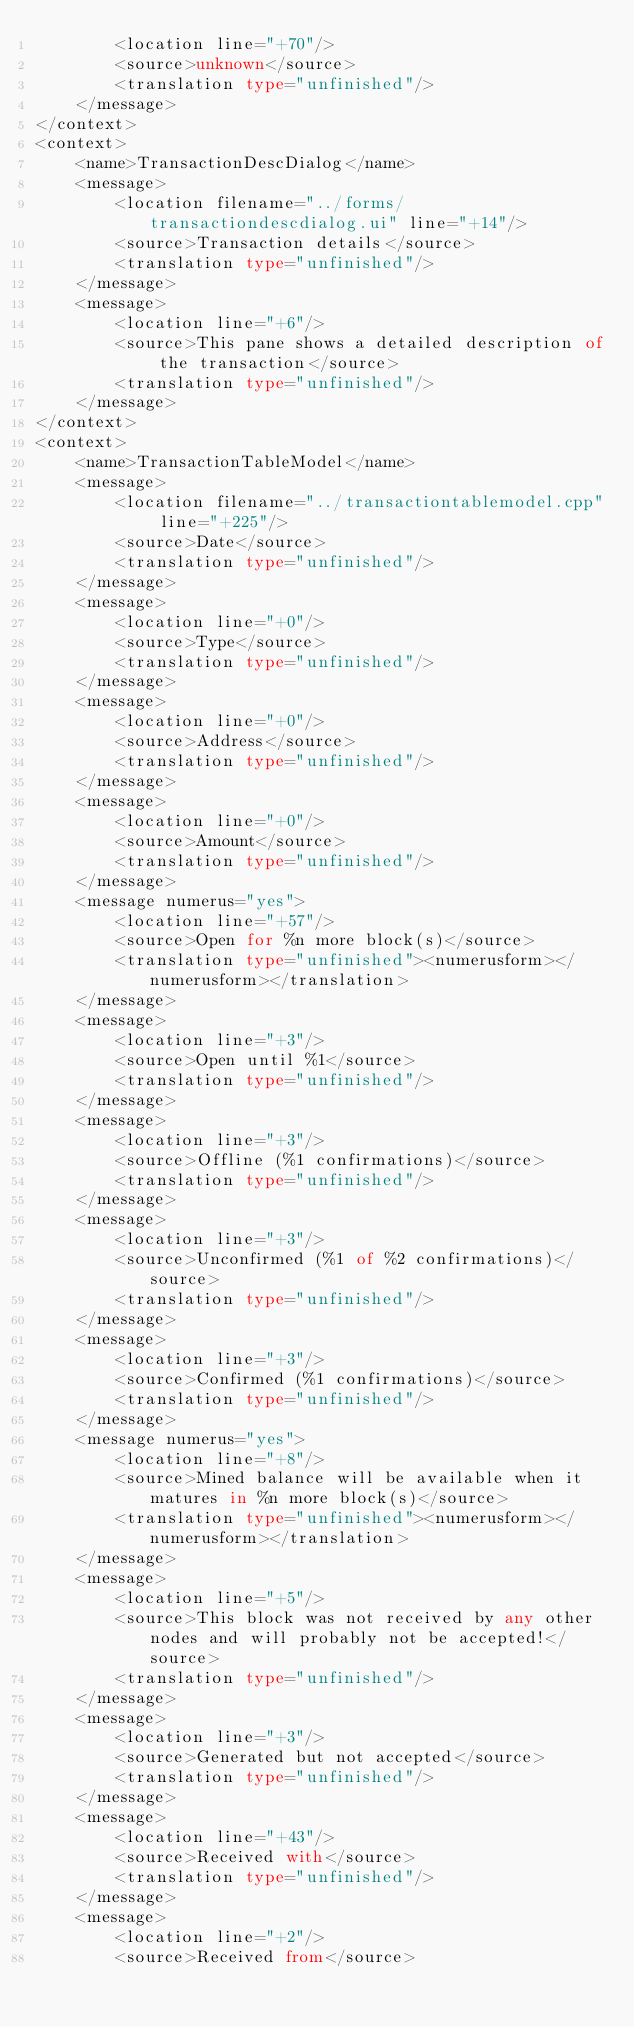Convert code to text. <code><loc_0><loc_0><loc_500><loc_500><_TypeScript_>        <location line="+70"/>
        <source>unknown</source>
        <translation type="unfinished"/>
    </message>
</context>
<context>
    <name>TransactionDescDialog</name>
    <message>
        <location filename="../forms/transactiondescdialog.ui" line="+14"/>
        <source>Transaction details</source>
        <translation type="unfinished"/>
    </message>
    <message>
        <location line="+6"/>
        <source>This pane shows a detailed description of the transaction</source>
        <translation type="unfinished"/>
    </message>
</context>
<context>
    <name>TransactionTableModel</name>
    <message>
        <location filename="../transactiontablemodel.cpp" line="+225"/>
        <source>Date</source>
        <translation type="unfinished"/>
    </message>
    <message>
        <location line="+0"/>
        <source>Type</source>
        <translation type="unfinished"/>
    </message>
    <message>
        <location line="+0"/>
        <source>Address</source>
        <translation type="unfinished"/>
    </message>
    <message>
        <location line="+0"/>
        <source>Amount</source>
        <translation type="unfinished"/>
    </message>
    <message numerus="yes">
        <location line="+57"/>
        <source>Open for %n more block(s)</source>
        <translation type="unfinished"><numerusform></numerusform></translation>
    </message>
    <message>
        <location line="+3"/>
        <source>Open until %1</source>
        <translation type="unfinished"/>
    </message>
    <message>
        <location line="+3"/>
        <source>Offline (%1 confirmations)</source>
        <translation type="unfinished"/>
    </message>
    <message>
        <location line="+3"/>
        <source>Unconfirmed (%1 of %2 confirmations)</source>
        <translation type="unfinished"/>
    </message>
    <message>
        <location line="+3"/>
        <source>Confirmed (%1 confirmations)</source>
        <translation type="unfinished"/>
    </message>
    <message numerus="yes">
        <location line="+8"/>
        <source>Mined balance will be available when it matures in %n more block(s)</source>
        <translation type="unfinished"><numerusform></numerusform></translation>
    </message>
    <message>
        <location line="+5"/>
        <source>This block was not received by any other nodes and will probably not be accepted!</source>
        <translation type="unfinished"/>
    </message>
    <message>
        <location line="+3"/>
        <source>Generated but not accepted</source>
        <translation type="unfinished"/>
    </message>
    <message>
        <location line="+43"/>
        <source>Received with</source>
        <translation type="unfinished"/>
    </message>
    <message>
        <location line="+2"/>
        <source>Received from</source></code> 